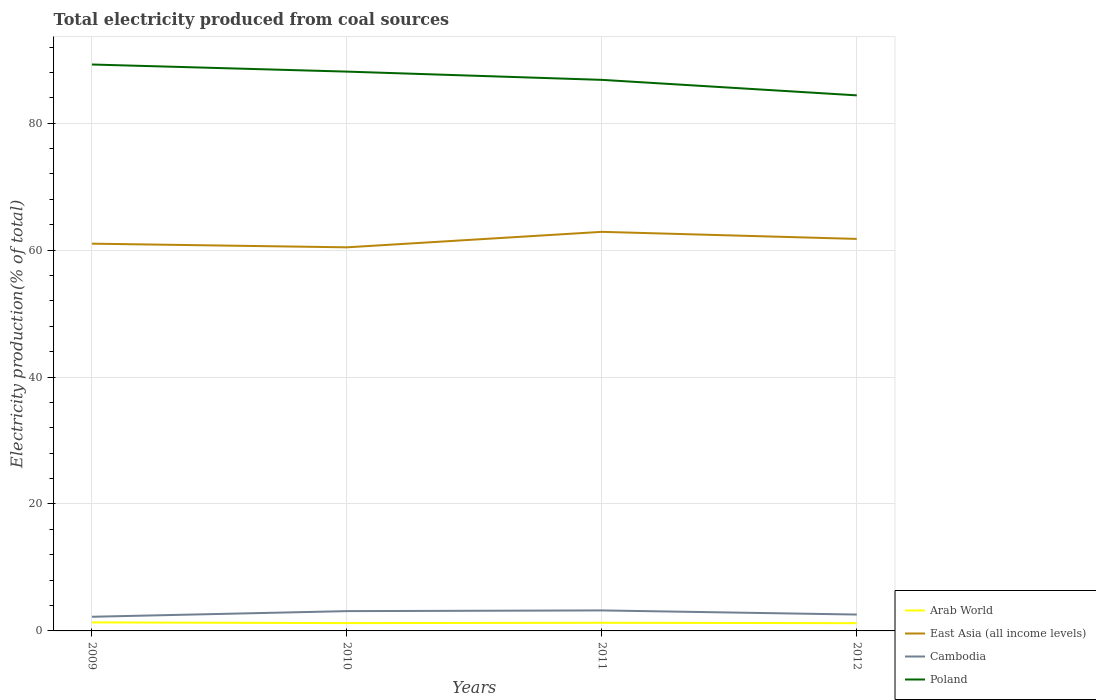Does the line corresponding to Cambodia intersect with the line corresponding to Poland?
Make the answer very short. No. Is the number of lines equal to the number of legend labels?
Keep it short and to the point. Yes. Across all years, what is the maximum total electricity produced in Cambodia?
Offer a very short reply. 2.23. What is the total total electricity produced in Cambodia in the graph?
Offer a very short reply. 0.65. What is the difference between the highest and the second highest total electricity produced in Cambodia?
Provide a short and direct response. 1. What is the difference between the highest and the lowest total electricity produced in Cambodia?
Your answer should be compact. 2. What is the difference between two consecutive major ticks on the Y-axis?
Provide a succinct answer. 20. Are the values on the major ticks of Y-axis written in scientific E-notation?
Provide a short and direct response. No. Does the graph contain any zero values?
Make the answer very short. No. How many legend labels are there?
Offer a very short reply. 4. How are the legend labels stacked?
Offer a very short reply. Vertical. What is the title of the graph?
Keep it short and to the point. Total electricity produced from coal sources. What is the Electricity production(% of total) of Arab World in 2009?
Provide a succinct answer. 1.34. What is the Electricity production(% of total) in East Asia (all income levels) in 2009?
Your answer should be compact. 61.02. What is the Electricity production(% of total) in Cambodia in 2009?
Your answer should be very brief. 2.23. What is the Electricity production(% of total) of Poland in 2009?
Your answer should be compact. 89.25. What is the Electricity production(% of total) of Arab World in 2010?
Offer a terse response. 1.23. What is the Electricity production(% of total) of East Asia (all income levels) in 2010?
Offer a very short reply. 60.44. What is the Electricity production(% of total) of Cambodia in 2010?
Provide a succinct answer. 3.12. What is the Electricity production(% of total) of Poland in 2010?
Your answer should be very brief. 88.13. What is the Electricity production(% of total) of Arab World in 2011?
Ensure brevity in your answer.  1.28. What is the Electricity production(% of total) in East Asia (all income levels) in 2011?
Your answer should be compact. 62.88. What is the Electricity production(% of total) in Cambodia in 2011?
Provide a succinct answer. 3.23. What is the Electricity production(% of total) of Poland in 2011?
Your answer should be very brief. 86.83. What is the Electricity production(% of total) of Arab World in 2012?
Ensure brevity in your answer.  1.22. What is the Electricity production(% of total) in East Asia (all income levels) in 2012?
Your answer should be very brief. 61.77. What is the Electricity production(% of total) in Cambodia in 2012?
Your response must be concise. 2.58. What is the Electricity production(% of total) in Poland in 2012?
Offer a terse response. 84.39. Across all years, what is the maximum Electricity production(% of total) of Arab World?
Your answer should be very brief. 1.34. Across all years, what is the maximum Electricity production(% of total) in East Asia (all income levels)?
Provide a short and direct response. 62.88. Across all years, what is the maximum Electricity production(% of total) of Cambodia?
Make the answer very short. 3.23. Across all years, what is the maximum Electricity production(% of total) of Poland?
Keep it short and to the point. 89.25. Across all years, what is the minimum Electricity production(% of total) in Arab World?
Your answer should be compact. 1.22. Across all years, what is the minimum Electricity production(% of total) of East Asia (all income levels)?
Your response must be concise. 60.44. Across all years, what is the minimum Electricity production(% of total) in Cambodia?
Ensure brevity in your answer.  2.23. Across all years, what is the minimum Electricity production(% of total) in Poland?
Provide a succinct answer. 84.39. What is the total Electricity production(% of total) in Arab World in the graph?
Your answer should be very brief. 5.08. What is the total Electricity production(% of total) in East Asia (all income levels) in the graph?
Provide a short and direct response. 246.11. What is the total Electricity production(% of total) in Cambodia in the graph?
Provide a short and direct response. 11.16. What is the total Electricity production(% of total) of Poland in the graph?
Your answer should be compact. 348.6. What is the difference between the Electricity production(% of total) of Arab World in 2009 and that in 2010?
Your answer should be compact. 0.11. What is the difference between the Electricity production(% of total) of East Asia (all income levels) in 2009 and that in 2010?
Provide a succinct answer. 0.58. What is the difference between the Electricity production(% of total) in Cambodia in 2009 and that in 2010?
Offer a terse response. -0.89. What is the difference between the Electricity production(% of total) of Poland in 2009 and that in 2010?
Make the answer very short. 1.12. What is the difference between the Electricity production(% of total) in Arab World in 2009 and that in 2011?
Provide a succinct answer. 0.06. What is the difference between the Electricity production(% of total) in East Asia (all income levels) in 2009 and that in 2011?
Ensure brevity in your answer.  -1.86. What is the difference between the Electricity production(% of total) of Cambodia in 2009 and that in 2011?
Offer a terse response. -1. What is the difference between the Electricity production(% of total) in Poland in 2009 and that in 2011?
Offer a very short reply. 2.42. What is the difference between the Electricity production(% of total) of Arab World in 2009 and that in 2012?
Provide a short and direct response. 0.12. What is the difference between the Electricity production(% of total) of East Asia (all income levels) in 2009 and that in 2012?
Ensure brevity in your answer.  -0.75. What is the difference between the Electricity production(% of total) of Cambodia in 2009 and that in 2012?
Your response must be concise. -0.35. What is the difference between the Electricity production(% of total) in Poland in 2009 and that in 2012?
Your response must be concise. 4.86. What is the difference between the Electricity production(% of total) of Arab World in 2010 and that in 2011?
Your answer should be compact. -0.05. What is the difference between the Electricity production(% of total) in East Asia (all income levels) in 2010 and that in 2011?
Your response must be concise. -2.44. What is the difference between the Electricity production(% of total) in Cambodia in 2010 and that in 2011?
Provide a succinct answer. -0.11. What is the difference between the Electricity production(% of total) in Poland in 2010 and that in 2011?
Keep it short and to the point. 1.3. What is the difference between the Electricity production(% of total) of Arab World in 2010 and that in 2012?
Offer a terse response. 0.01. What is the difference between the Electricity production(% of total) in East Asia (all income levels) in 2010 and that in 2012?
Give a very brief answer. -1.33. What is the difference between the Electricity production(% of total) of Cambodia in 2010 and that in 2012?
Give a very brief answer. 0.54. What is the difference between the Electricity production(% of total) of Poland in 2010 and that in 2012?
Your answer should be very brief. 3.74. What is the difference between the Electricity production(% of total) in Arab World in 2011 and that in 2012?
Offer a very short reply. 0.06. What is the difference between the Electricity production(% of total) of East Asia (all income levels) in 2011 and that in 2012?
Keep it short and to the point. 1.11. What is the difference between the Electricity production(% of total) of Cambodia in 2011 and that in 2012?
Give a very brief answer. 0.65. What is the difference between the Electricity production(% of total) in Poland in 2011 and that in 2012?
Your answer should be very brief. 2.44. What is the difference between the Electricity production(% of total) of Arab World in 2009 and the Electricity production(% of total) of East Asia (all income levels) in 2010?
Give a very brief answer. -59.1. What is the difference between the Electricity production(% of total) in Arab World in 2009 and the Electricity production(% of total) in Cambodia in 2010?
Your response must be concise. -1.78. What is the difference between the Electricity production(% of total) in Arab World in 2009 and the Electricity production(% of total) in Poland in 2010?
Make the answer very short. -86.79. What is the difference between the Electricity production(% of total) of East Asia (all income levels) in 2009 and the Electricity production(% of total) of Cambodia in 2010?
Give a very brief answer. 57.9. What is the difference between the Electricity production(% of total) in East Asia (all income levels) in 2009 and the Electricity production(% of total) in Poland in 2010?
Your answer should be compact. -27.11. What is the difference between the Electricity production(% of total) of Cambodia in 2009 and the Electricity production(% of total) of Poland in 2010?
Keep it short and to the point. -85.9. What is the difference between the Electricity production(% of total) of Arab World in 2009 and the Electricity production(% of total) of East Asia (all income levels) in 2011?
Provide a succinct answer. -61.54. What is the difference between the Electricity production(% of total) in Arab World in 2009 and the Electricity production(% of total) in Cambodia in 2011?
Provide a short and direct response. -1.89. What is the difference between the Electricity production(% of total) in Arab World in 2009 and the Electricity production(% of total) in Poland in 2011?
Your answer should be compact. -85.49. What is the difference between the Electricity production(% of total) of East Asia (all income levels) in 2009 and the Electricity production(% of total) of Cambodia in 2011?
Offer a terse response. 57.79. What is the difference between the Electricity production(% of total) of East Asia (all income levels) in 2009 and the Electricity production(% of total) of Poland in 2011?
Provide a short and direct response. -25.81. What is the difference between the Electricity production(% of total) in Cambodia in 2009 and the Electricity production(% of total) in Poland in 2011?
Offer a terse response. -84.6. What is the difference between the Electricity production(% of total) in Arab World in 2009 and the Electricity production(% of total) in East Asia (all income levels) in 2012?
Your answer should be very brief. -60.43. What is the difference between the Electricity production(% of total) in Arab World in 2009 and the Electricity production(% of total) in Cambodia in 2012?
Make the answer very short. -1.24. What is the difference between the Electricity production(% of total) in Arab World in 2009 and the Electricity production(% of total) in Poland in 2012?
Your response must be concise. -83.04. What is the difference between the Electricity production(% of total) of East Asia (all income levels) in 2009 and the Electricity production(% of total) of Cambodia in 2012?
Give a very brief answer. 58.44. What is the difference between the Electricity production(% of total) in East Asia (all income levels) in 2009 and the Electricity production(% of total) in Poland in 2012?
Offer a terse response. -23.37. What is the difference between the Electricity production(% of total) in Cambodia in 2009 and the Electricity production(% of total) in Poland in 2012?
Provide a succinct answer. -82.16. What is the difference between the Electricity production(% of total) of Arab World in 2010 and the Electricity production(% of total) of East Asia (all income levels) in 2011?
Offer a very short reply. -61.65. What is the difference between the Electricity production(% of total) of Arab World in 2010 and the Electricity production(% of total) of Cambodia in 2011?
Offer a terse response. -2. What is the difference between the Electricity production(% of total) of Arab World in 2010 and the Electricity production(% of total) of Poland in 2011?
Your answer should be compact. -85.6. What is the difference between the Electricity production(% of total) of East Asia (all income levels) in 2010 and the Electricity production(% of total) of Cambodia in 2011?
Provide a short and direct response. 57.21. What is the difference between the Electricity production(% of total) of East Asia (all income levels) in 2010 and the Electricity production(% of total) of Poland in 2011?
Your response must be concise. -26.39. What is the difference between the Electricity production(% of total) of Cambodia in 2010 and the Electricity production(% of total) of Poland in 2011?
Your answer should be compact. -83.71. What is the difference between the Electricity production(% of total) of Arab World in 2010 and the Electricity production(% of total) of East Asia (all income levels) in 2012?
Make the answer very short. -60.54. What is the difference between the Electricity production(% of total) in Arab World in 2010 and the Electricity production(% of total) in Cambodia in 2012?
Your response must be concise. -1.35. What is the difference between the Electricity production(% of total) in Arab World in 2010 and the Electricity production(% of total) in Poland in 2012?
Keep it short and to the point. -83.16. What is the difference between the Electricity production(% of total) in East Asia (all income levels) in 2010 and the Electricity production(% of total) in Cambodia in 2012?
Provide a succinct answer. 57.86. What is the difference between the Electricity production(% of total) of East Asia (all income levels) in 2010 and the Electricity production(% of total) of Poland in 2012?
Offer a very short reply. -23.95. What is the difference between the Electricity production(% of total) of Cambodia in 2010 and the Electricity production(% of total) of Poland in 2012?
Provide a short and direct response. -81.27. What is the difference between the Electricity production(% of total) of Arab World in 2011 and the Electricity production(% of total) of East Asia (all income levels) in 2012?
Offer a terse response. -60.49. What is the difference between the Electricity production(% of total) in Arab World in 2011 and the Electricity production(% of total) in Cambodia in 2012?
Your response must be concise. -1.3. What is the difference between the Electricity production(% of total) of Arab World in 2011 and the Electricity production(% of total) of Poland in 2012?
Make the answer very short. -83.11. What is the difference between the Electricity production(% of total) of East Asia (all income levels) in 2011 and the Electricity production(% of total) of Cambodia in 2012?
Ensure brevity in your answer.  60.3. What is the difference between the Electricity production(% of total) of East Asia (all income levels) in 2011 and the Electricity production(% of total) of Poland in 2012?
Offer a very short reply. -21.51. What is the difference between the Electricity production(% of total) of Cambodia in 2011 and the Electricity production(% of total) of Poland in 2012?
Provide a succinct answer. -81.16. What is the average Electricity production(% of total) in Arab World per year?
Ensure brevity in your answer.  1.27. What is the average Electricity production(% of total) in East Asia (all income levels) per year?
Provide a succinct answer. 61.53. What is the average Electricity production(% of total) in Cambodia per year?
Offer a terse response. 2.79. What is the average Electricity production(% of total) in Poland per year?
Keep it short and to the point. 87.15. In the year 2009, what is the difference between the Electricity production(% of total) in Arab World and Electricity production(% of total) in East Asia (all income levels)?
Ensure brevity in your answer.  -59.68. In the year 2009, what is the difference between the Electricity production(% of total) in Arab World and Electricity production(% of total) in Cambodia?
Make the answer very short. -0.89. In the year 2009, what is the difference between the Electricity production(% of total) in Arab World and Electricity production(% of total) in Poland?
Provide a short and direct response. -87.91. In the year 2009, what is the difference between the Electricity production(% of total) in East Asia (all income levels) and Electricity production(% of total) in Cambodia?
Give a very brief answer. 58.79. In the year 2009, what is the difference between the Electricity production(% of total) of East Asia (all income levels) and Electricity production(% of total) of Poland?
Ensure brevity in your answer.  -28.23. In the year 2009, what is the difference between the Electricity production(% of total) of Cambodia and Electricity production(% of total) of Poland?
Give a very brief answer. -87.02. In the year 2010, what is the difference between the Electricity production(% of total) of Arab World and Electricity production(% of total) of East Asia (all income levels)?
Offer a terse response. -59.21. In the year 2010, what is the difference between the Electricity production(% of total) in Arab World and Electricity production(% of total) in Cambodia?
Your answer should be very brief. -1.89. In the year 2010, what is the difference between the Electricity production(% of total) in Arab World and Electricity production(% of total) in Poland?
Your response must be concise. -86.9. In the year 2010, what is the difference between the Electricity production(% of total) of East Asia (all income levels) and Electricity production(% of total) of Cambodia?
Ensure brevity in your answer.  57.32. In the year 2010, what is the difference between the Electricity production(% of total) in East Asia (all income levels) and Electricity production(% of total) in Poland?
Ensure brevity in your answer.  -27.69. In the year 2010, what is the difference between the Electricity production(% of total) of Cambodia and Electricity production(% of total) of Poland?
Your response must be concise. -85.01. In the year 2011, what is the difference between the Electricity production(% of total) in Arab World and Electricity production(% of total) in East Asia (all income levels)?
Offer a terse response. -61.6. In the year 2011, what is the difference between the Electricity production(% of total) of Arab World and Electricity production(% of total) of Cambodia?
Your answer should be very brief. -1.95. In the year 2011, what is the difference between the Electricity production(% of total) in Arab World and Electricity production(% of total) in Poland?
Provide a succinct answer. -85.55. In the year 2011, what is the difference between the Electricity production(% of total) in East Asia (all income levels) and Electricity production(% of total) in Cambodia?
Offer a terse response. 59.65. In the year 2011, what is the difference between the Electricity production(% of total) in East Asia (all income levels) and Electricity production(% of total) in Poland?
Offer a very short reply. -23.95. In the year 2011, what is the difference between the Electricity production(% of total) in Cambodia and Electricity production(% of total) in Poland?
Offer a terse response. -83.6. In the year 2012, what is the difference between the Electricity production(% of total) of Arab World and Electricity production(% of total) of East Asia (all income levels)?
Ensure brevity in your answer.  -60.55. In the year 2012, what is the difference between the Electricity production(% of total) in Arab World and Electricity production(% of total) in Cambodia?
Your answer should be compact. -1.36. In the year 2012, what is the difference between the Electricity production(% of total) in Arab World and Electricity production(% of total) in Poland?
Give a very brief answer. -83.17. In the year 2012, what is the difference between the Electricity production(% of total) in East Asia (all income levels) and Electricity production(% of total) in Cambodia?
Provide a succinct answer. 59.19. In the year 2012, what is the difference between the Electricity production(% of total) in East Asia (all income levels) and Electricity production(% of total) in Poland?
Provide a short and direct response. -22.62. In the year 2012, what is the difference between the Electricity production(% of total) in Cambodia and Electricity production(% of total) in Poland?
Provide a succinct answer. -81.81. What is the ratio of the Electricity production(% of total) in East Asia (all income levels) in 2009 to that in 2010?
Provide a short and direct response. 1.01. What is the ratio of the Electricity production(% of total) of Cambodia in 2009 to that in 2010?
Provide a succinct answer. 0.71. What is the ratio of the Electricity production(% of total) in Poland in 2009 to that in 2010?
Keep it short and to the point. 1.01. What is the ratio of the Electricity production(% of total) in Arab World in 2009 to that in 2011?
Provide a succinct answer. 1.05. What is the ratio of the Electricity production(% of total) in East Asia (all income levels) in 2009 to that in 2011?
Give a very brief answer. 0.97. What is the ratio of the Electricity production(% of total) in Cambodia in 2009 to that in 2011?
Offer a very short reply. 0.69. What is the ratio of the Electricity production(% of total) in Poland in 2009 to that in 2011?
Make the answer very short. 1.03. What is the ratio of the Electricity production(% of total) in Arab World in 2009 to that in 2012?
Provide a short and direct response. 1.1. What is the ratio of the Electricity production(% of total) of East Asia (all income levels) in 2009 to that in 2012?
Your answer should be compact. 0.99. What is the ratio of the Electricity production(% of total) of Cambodia in 2009 to that in 2012?
Make the answer very short. 0.86. What is the ratio of the Electricity production(% of total) of Poland in 2009 to that in 2012?
Make the answer very short. 1.06. What is the ratio of the Electricity production(% of total) of Arab World in 2010 to that in 2011?
Give a very brief answer. 0.96. What is the ratio of the Electricity production(% of total) in East Asia (all income levels) in 2010 to that in 2011?
Make the answer very short. 0.96. What is the ratio of the Electricity production(% of total) in Cambodia in 2010 to that in 2011?
Make the answer very short. 0.97. What is the ratio of the Electricity production(% of total) of Arab World in 2010 to that in 2012?
Your answer should be very brief. 1.01. What is the ratio of the Electricity production(% of total) of East Asia (all income levels) in 2010 to that in 2012?
Ensure brevity in your answer.  0.98. What is the ratio of the Electricity production(% of total) in Cambodia in 2010 to that in 2012?
Your answer should be compact. 1.21. What is the ratio of the Electricity production(% of total) in Poland in 2010 to that in 2012?
Provide a succinct answer. 1.04. What is the ratio of the Electricity production(% of total) in Arab World in 2011 to that in 2012?
Provide a succinct answer. 1.05. What is the ratio of the Electricity production(% of total) in Cambodia in 2011 to that in 2012?
Offer a terse response. 1.25. What is the ratio of the Electricity production(% of total) of Poland in 2011 to that in 2012?
Give a very brief answer. 1.03. What is the difference between the highest and the second highest Electricity production(% of total) in Arab World?
Ensure brevity in your answer.  0.06. What is the difference between the highest and the second highest Electricity production(% of total) of East Asia (all income levels)?
Offer a terse response. 1.11. What is the difference between the highest and the second highest Electricity production(% of total) of Cambodia?
Provide a succinct answer. 0.11. What is the difference between the highest and the second highest Electricity production(% of total) of Poland?
Offer a terse response. 1.12. What is the difference between the highest and the lowest Electricity production(% of total) in Arab World?
Your answer should be very brief. 0.12. What is the difference between the highest and the lowest Electricity production(% of total) of East Asia (all income levels)?
Keep it short and to the point. 2.44. What is the difference between the highest and the lowest Electricity production(% of total) in Cambodia?
Provide a succinct answer. 1. What is the difference between the highest and the lowest Electricity production(% of total) of Poland?
Provide a short and direct response. 4.86. 